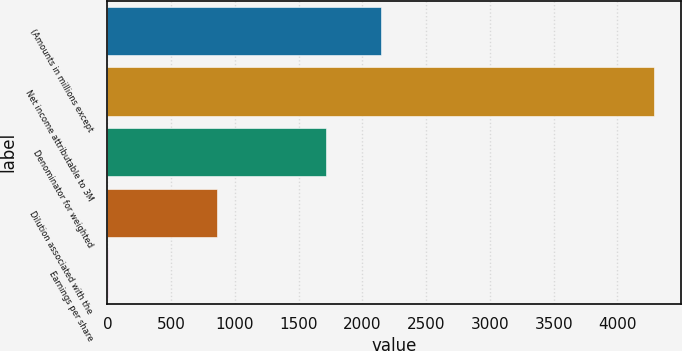<chart> <loc_0><loc_0><loc_500><loc_500><bar_chart><fcel>(Amounts in millions except<fcel>Net income attributable to 3M<fcel>Denominator for weighted<fcel>Dilution associated with the<fcel>Earnings per share<nl><fcel>2144.46<fcel>4283<fcel>1716.76<fcel>861.36<fcel>5.96<nl></chart> 